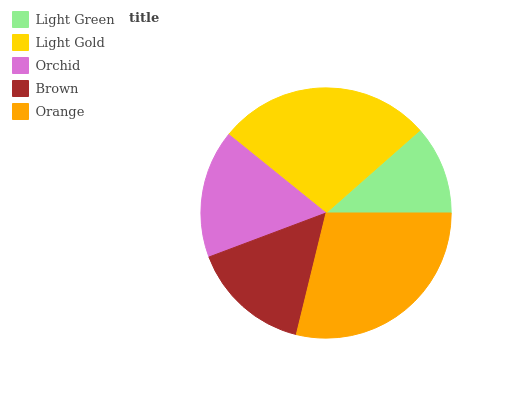Is Light Green the minimum?
Answer yes or no. Yes. Is Orange the maximum?
Answer yes or no. Yes. Is Light Gold the minimum?
Answer yes or no. No. Is Light Gold the maximum?
Answer yes or no. No. Is Light Gold greater than Light Green?
Answer yes or no. Yes. Is Light Green less than Light Gold?
Answer yes or no. Yes. Is Light Green greater than Light Gold?
Answer yes or no. No. Is Light Gold less than Light Green?
Answer yes or no. No. Is Orchid the high median?
Answer yes or no. Yes. Is Orchid the low median?
Answer yes or no. Yes. Is Light Green the high median?
Answer yes or no. No. Is Light Green the low median?
Answer yes or no. No. 